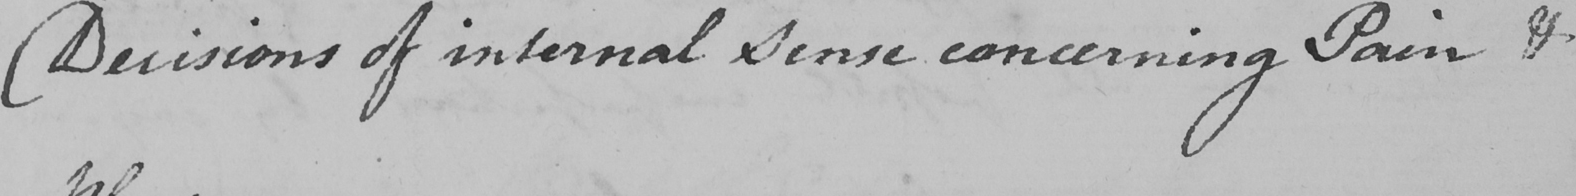Please transcribe the handwritten text in this image. Decisions of internal Sense concerning Pain & 